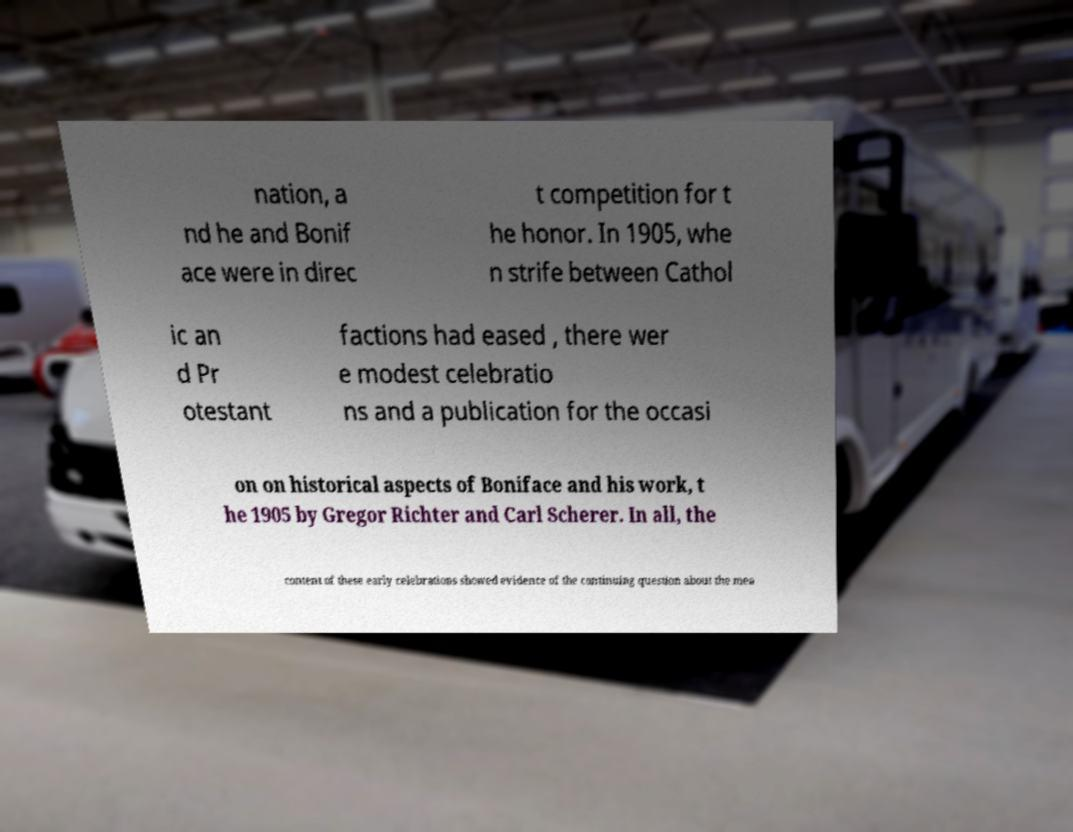Please read and relay the text visible in this image. What does it say? nation, a nd he and Bonif ace were in direc t competition for t he honor. In 1905, whe n strife between Cathol ic an d Pr otestant factions had eased , there wer e modest celebratio ns and a publication for the occasi on on historical aspects of Boniface and his work, t he 1905 by Gregor Richter and Carl Scherer. In all, the content of these early celebrations showed evidence of the continuing question about the mea 